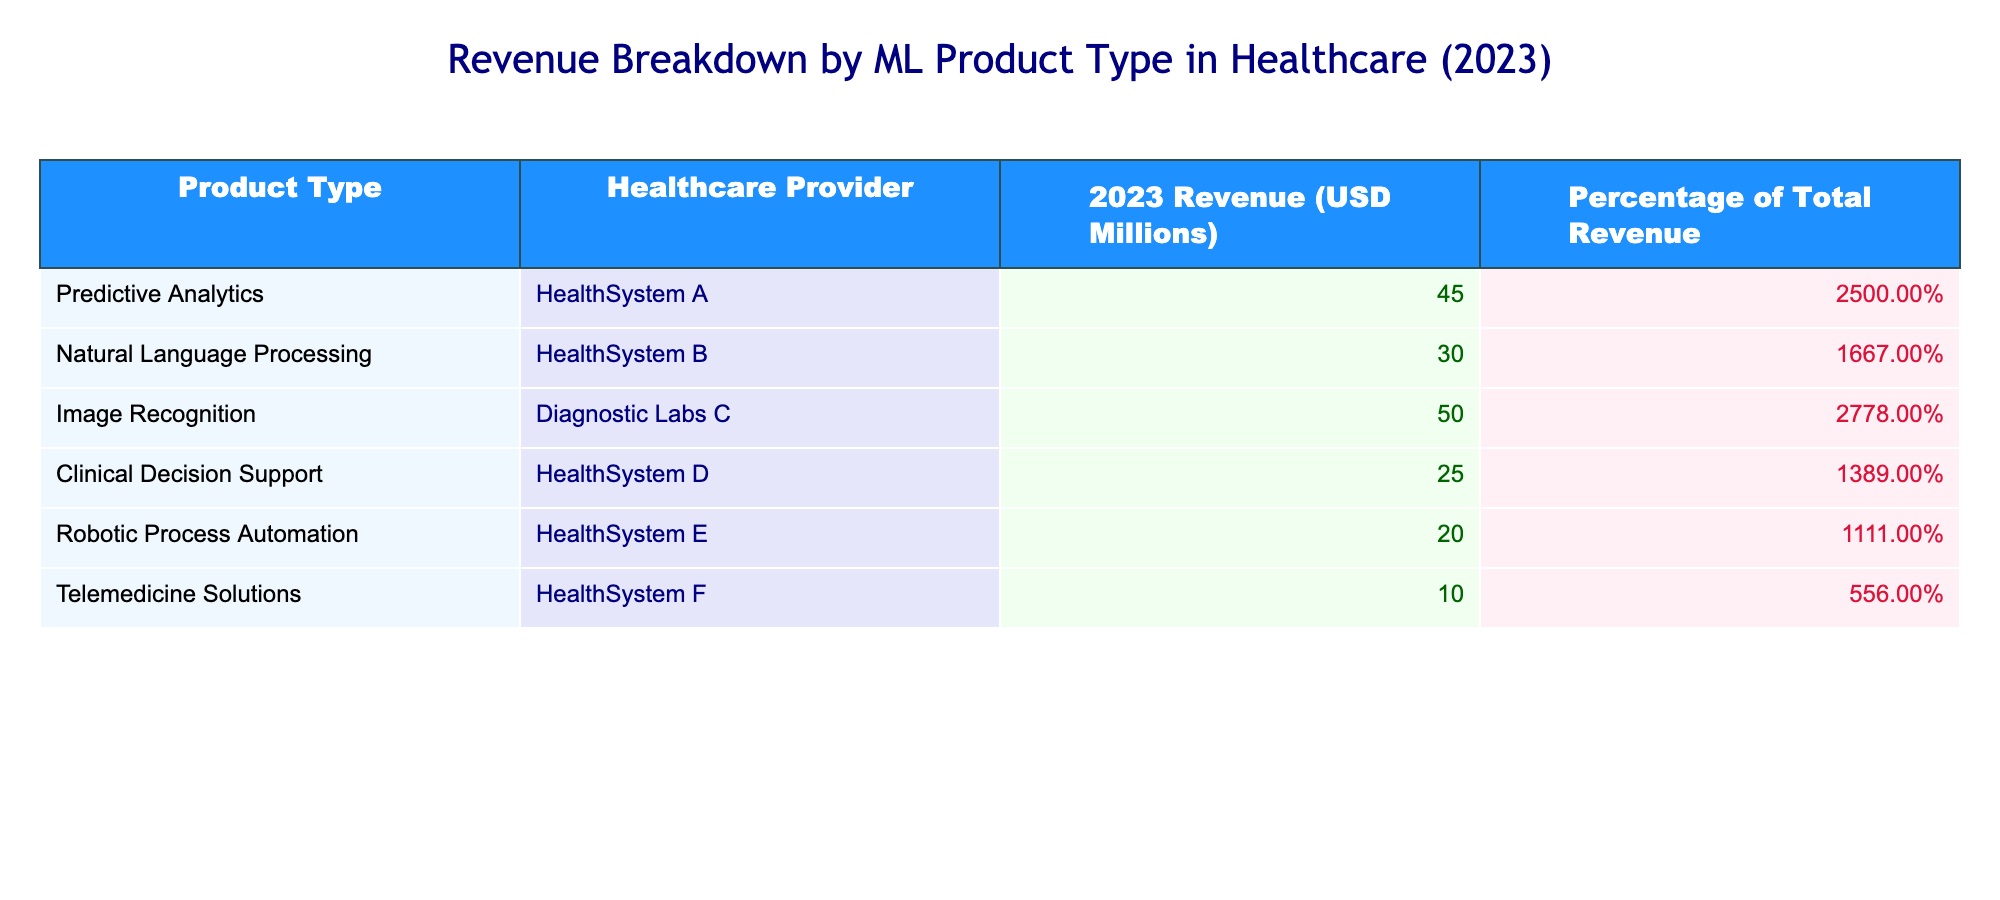What is the total revenue generated by all healthcare providers from predictive analytics? To find the total revenue from predictive analytics, look at the row for predictive analytics in the revenue column. The revenue is 45 million USD.
Answer: 45 million USD What percentage of the total revenue comes from image recognition? The table shows that image recognition contributes 27.78% to the total revenue for 2023.
Answer: 27.78% Is clinical decision support the product type with the lowest revenue? By comparing the revenue values, clinical decision support has a revenue of 25 million, while telemedicine solutions have only 10 million. Therefore, clinical decision support is not the lowest.
Answer: No Calculate the average revenue across all machine learning product types listed. The revenue values for each product type are 45, 30, 50, 25, 20, and 10 million. Summing these values gives 180 million USD. Since there are 6 product types, the average revenue is 180 / 6 = 30 million USD.
Answer: 30 million USD Which healthcare provider generated the highest revenue, and how much was it? From the table, diagnostic labs C generated the highest revenue of 50 million USD.
Answer: Diagnostic Labs C, 50 million USD What is the difference in revenue between natural language processing and robotic process automation? The revenue for natural language processing is 30 million USD, while robotic process automation has 20 million USD. The difference in revenue is 30 - 20 = 10 million USD.
Answer: 10 million USD Does telemedicine solutions contribute to more than 10% of the total revenue? The percentage contribution of telemedicine solutions is shown as 5.56%, which is less than 10%.
Answer: No How much total revenue is generated by healthcare providers for product types that contribute over 20% of total revenue? The product types that contribute over 20% are predictive analytics (45 million) and image recognition (50 million). Thus, the total is 45 + 50 = 95 million USD.
Answer: 95 million USD Which healthcare provider earns less than 20 million USD from their machine learning products? According to the table, health system E has robotic process automation earning 20 million, but health system F with telemedicine solutions earns only 10 million USD. Hence, health system F earns less than 20 million.
Answer: HealthSystem F 